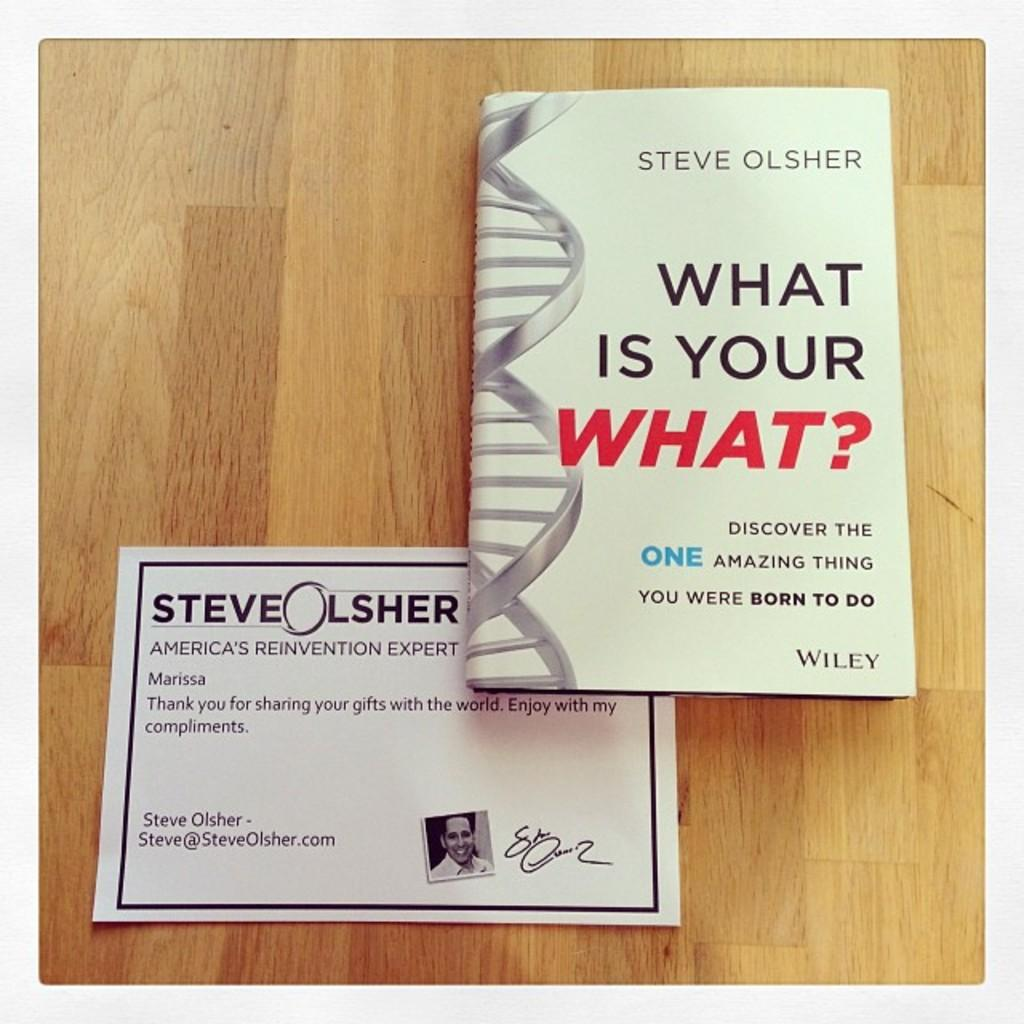<image>
Summarize the visual content of the image. A book on a wooden surface called What Is Your What. 